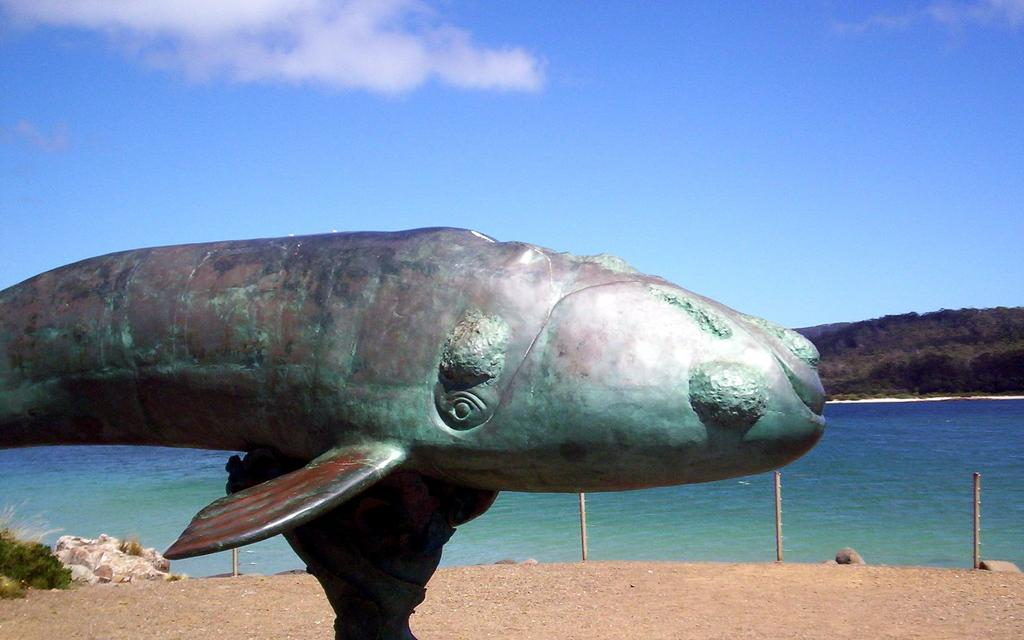What is the main subject in the image? There is a statue in the image. What else can be seen in the image besides the statue? There are poles, water, grass, and trees visible in the image. What is the background of the image like? The background of the image includes trees and the sky. What can be observed in the sky? Clouds are present in the sky. What is the chance of winning a flight to the moon in the image? There is no mention of a flight to the moon or any chance of winning in the image. 